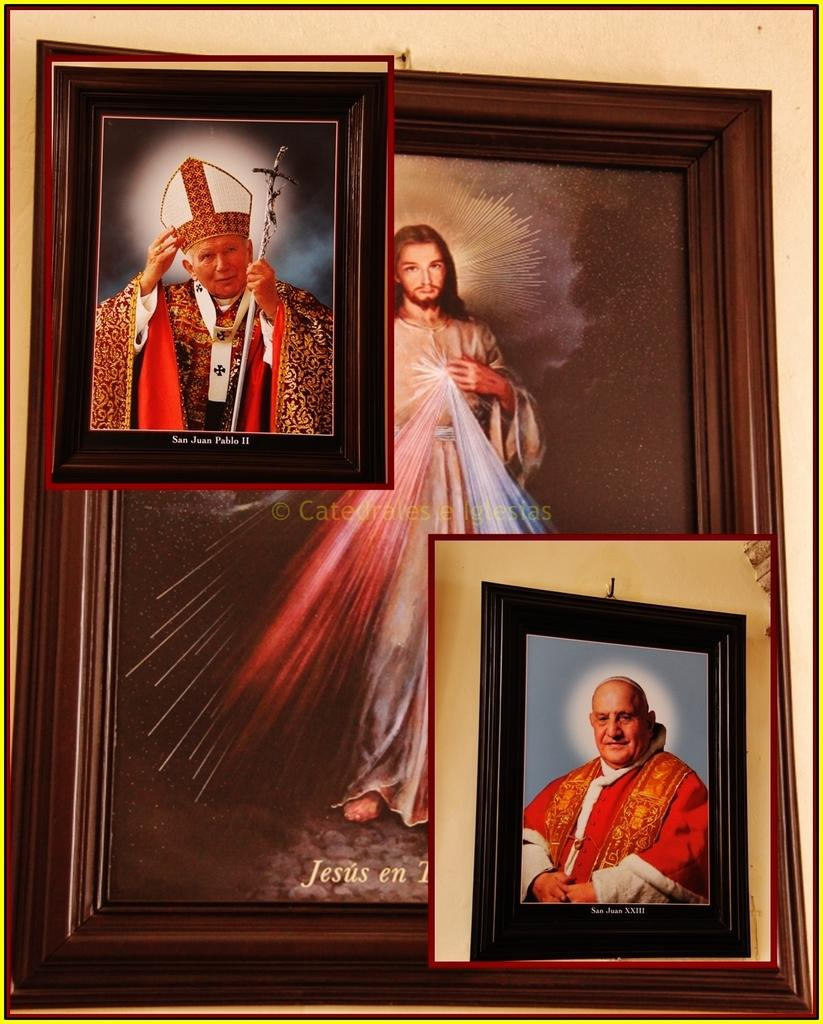Provide a one-sentence caption for the provided image. A picture San Juan Pablo II is sitting on top of a picture of Jesus. 